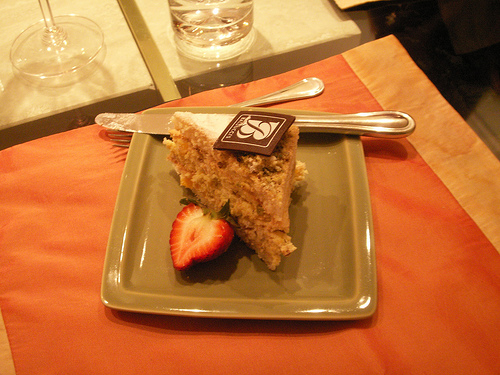<image>
Can you confirm if the letter b is on the cake? Yes. Looking at the image, I can see the letter b is positioned on top of the cake, with the cake providing support. Is the cake in the plate? Yes. The cake is contained within or inside the plate, showing a containment relationship. Is the knife in the cake? No. The knife is not contained within the cake. These objects have a different spatial relationship. 